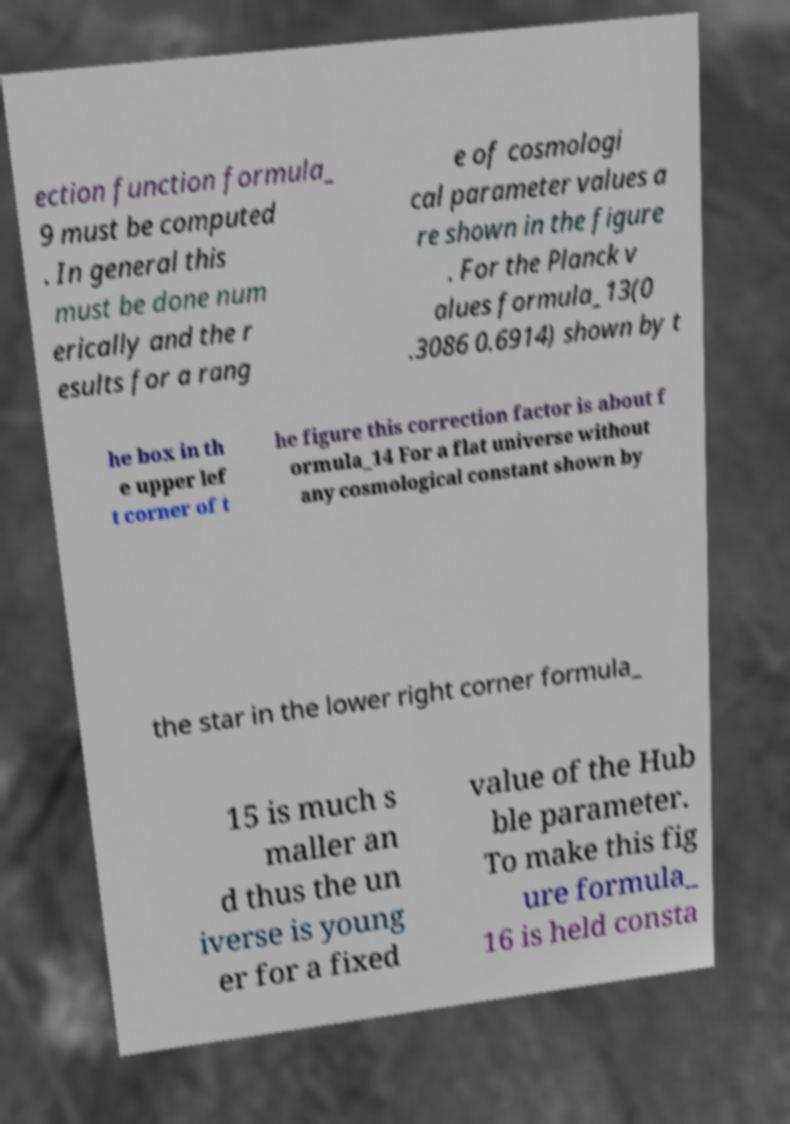Could you assist in decoding the text presented in this image and type it out clearly? ection function formula_ 9 must be computed . In general this must be done num erically and the r esults for a rang e of cosmologi cal parameter values a re shown in the figure . For the Planck v alues formula_13(0 .3086 0.6914) shown by t he box in th e upper lef t corner of t he figure this correction factor is about f ormula_14 For a flat universe without any cosmological constant shown by the star in the lower right corner formula_ 15 is much s maller an d thus the un iverse is young er for a fixed value of the Hub ble parameter. To make this fig ure formula_ 16 is held consta 